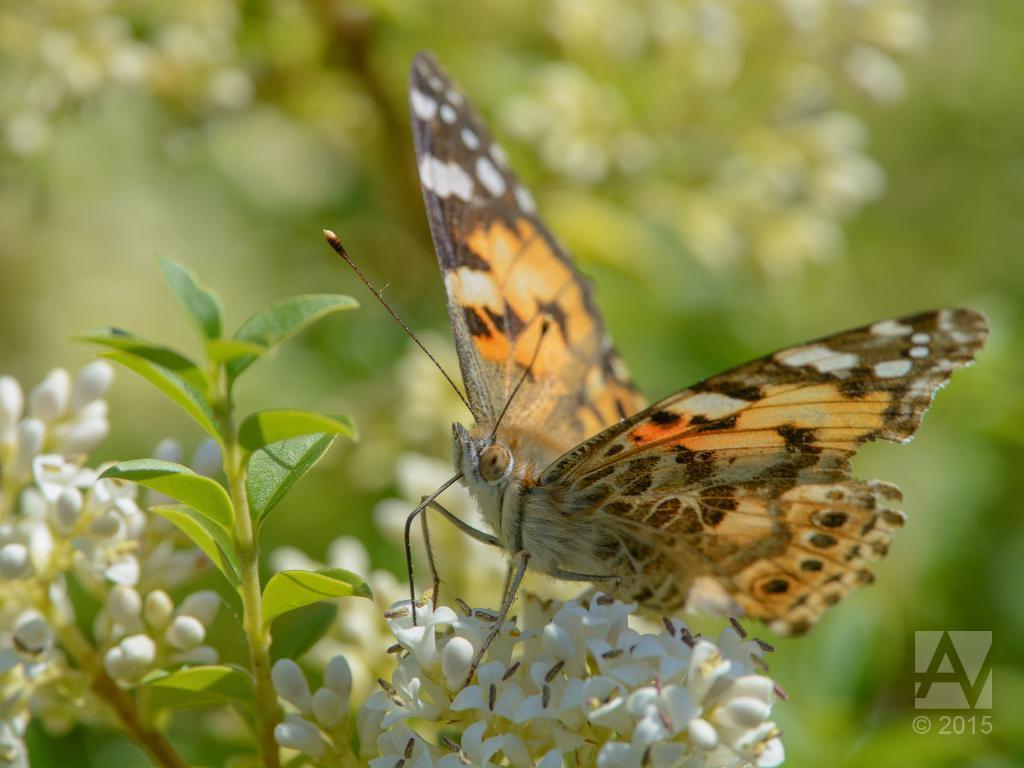How would you summarize this image in a sentence or two? In this image I can see the butterfly on the white color flowers. Butterfly is in brown, black and white, orange color. Background is in green color. 